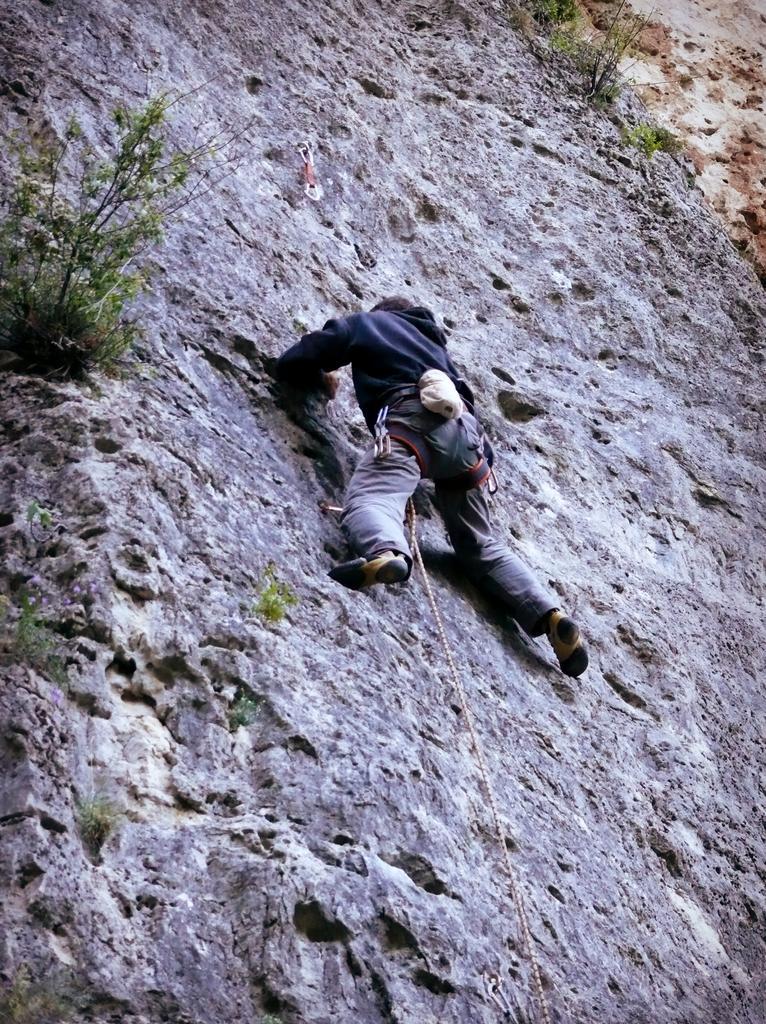In one or two sentences, can you explain what this image depicts? In this image we can see a person climbing the mountain and we can see some plants. 